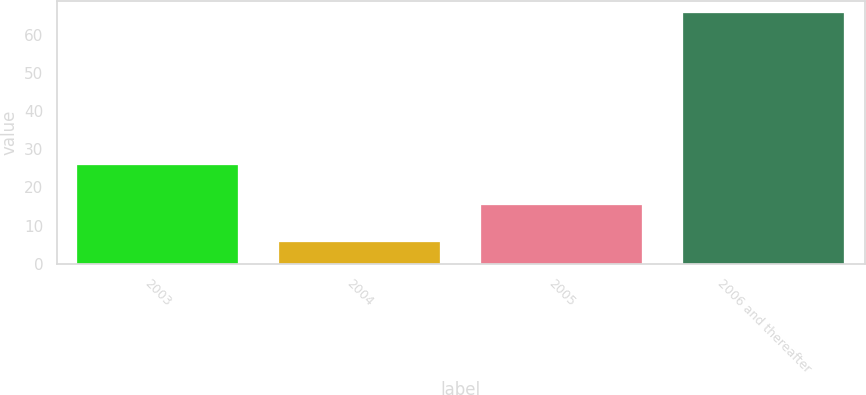Convert chart to OTSL. <chart><loc_0><loc_0><loc_500><loc_500><bar_chart><fcel>2003<fcel>2004<fcel>2005<fcel>2006 and thereafter<nl><fcel>25.8<fcel>5.8<fcel>15.3<fcel>65.6<nl></chart> 